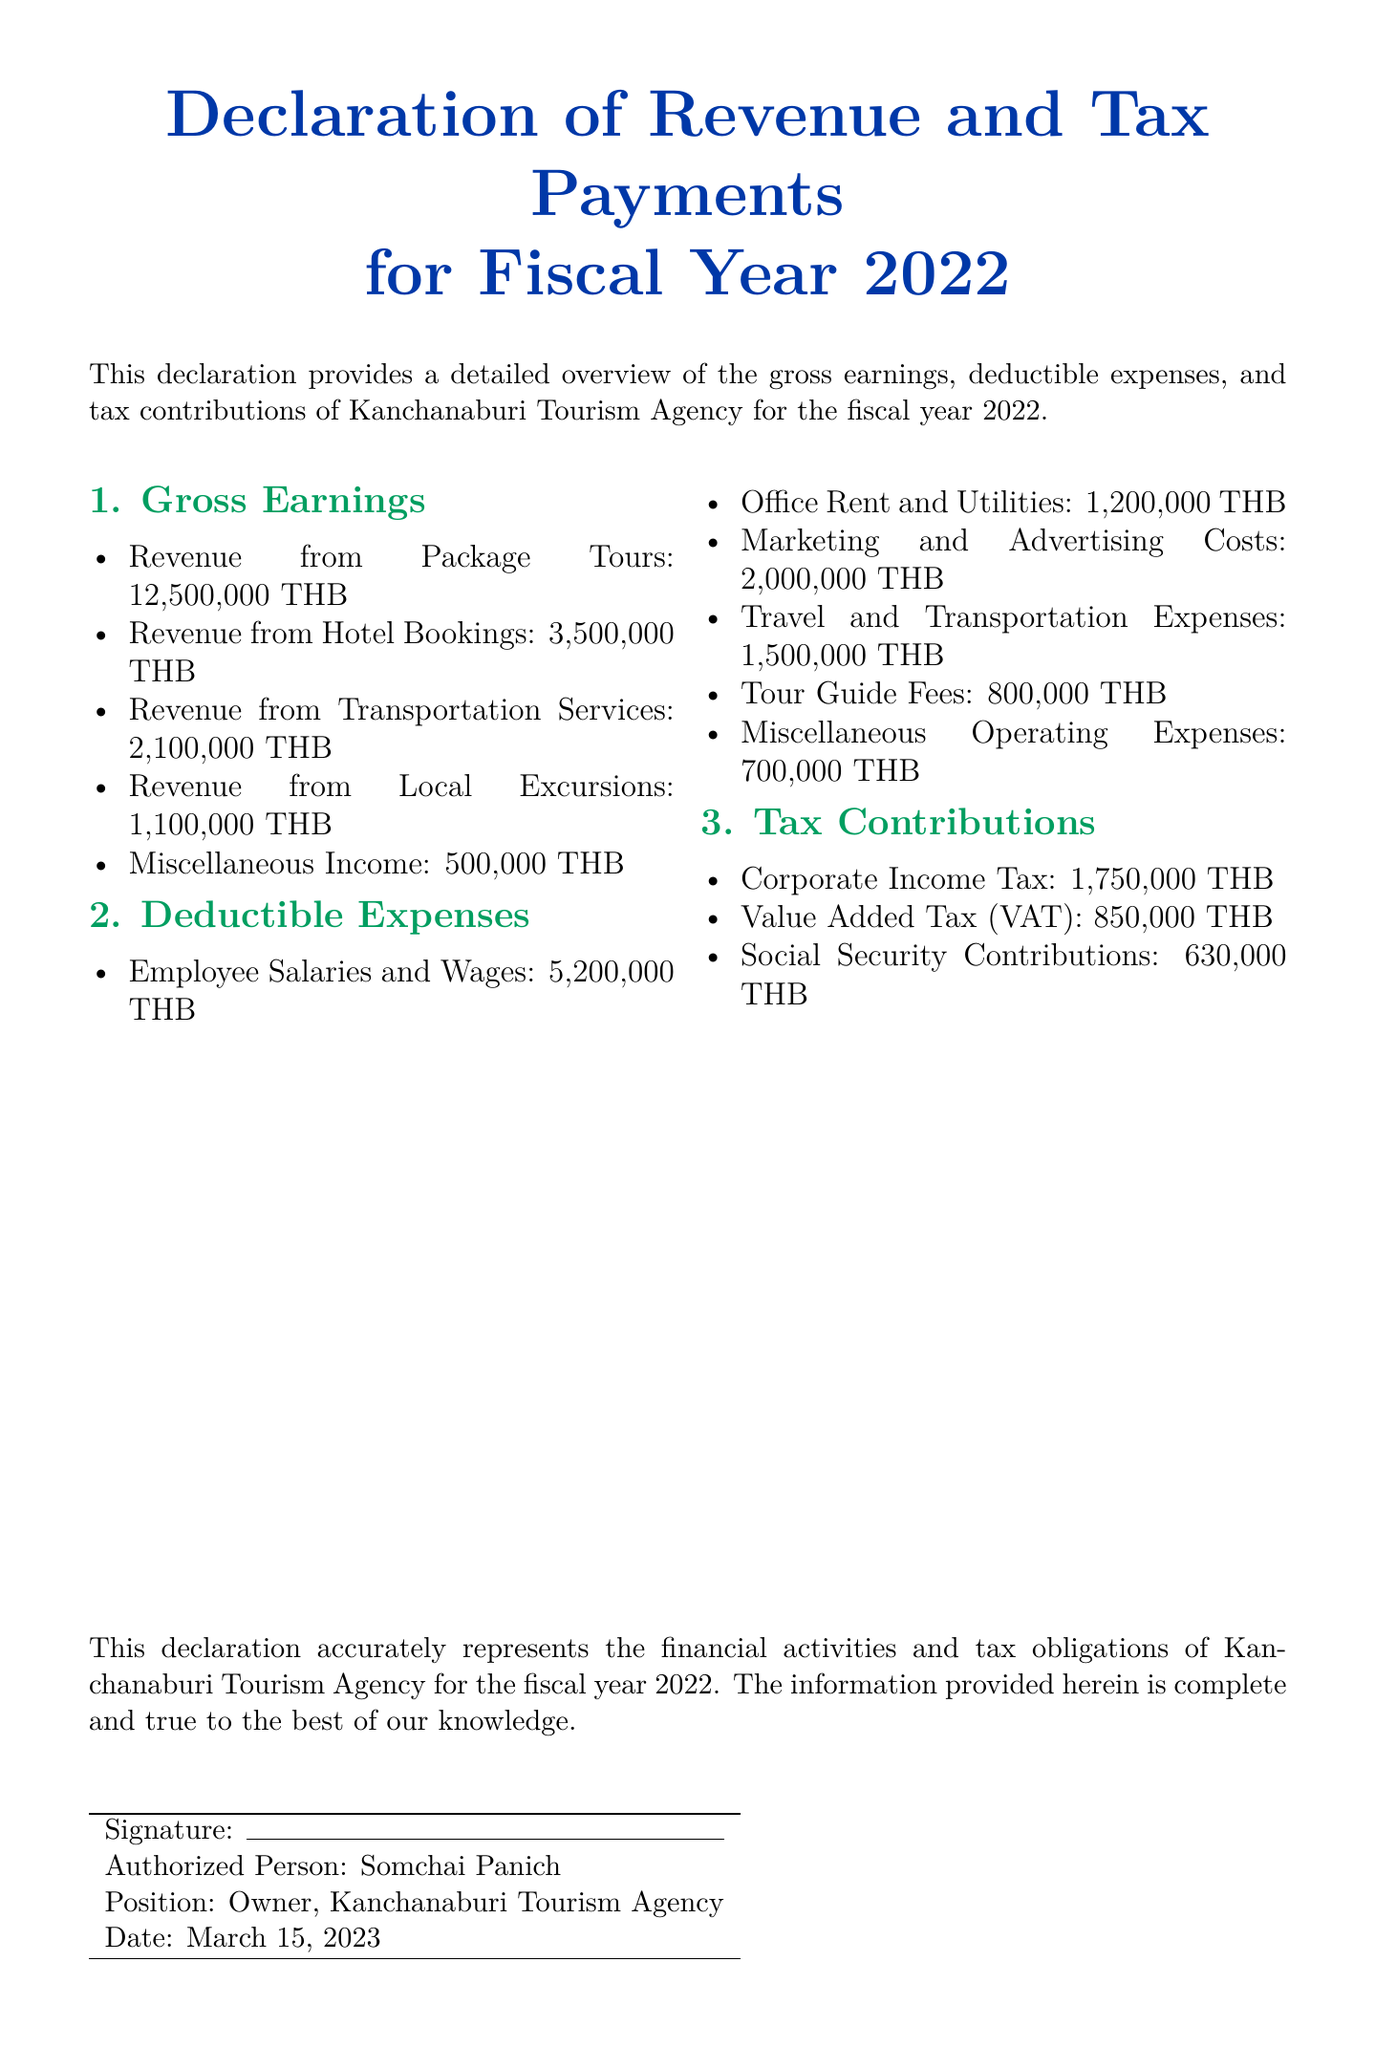What is the total revenue from Package Tours? The total revenue from Package Tours is explicitly stated in the document.
Answer: 12,500,000 THB What is the amount allocated for Employee Salaries and Wages? The amount for Employee Salaries and Wages is listed under deductible expenses.
Answer: 5,200,000 THB What is the date of the declaration? The date of the declaration is mentioned at the end of the document.
Answer: March 15, 2023 Who is the authorized person signing the document? The authorized person is specified in the signature section.
Answer: Somchai Panich How much is contributed for Social Security Contributions? The amount for Social Security Contributions can be found in the tax contributions section.
Answer: 630,000 THB What is the total amount of corporate income tax? The total amount of corporate income tax is clearly noted in the tax contributions section of the document.
Answer: 1,750,000 THB What is the sum of deductible expenses? The sum of deductible expenses requires adding all listed expenses together.
Answer: 12,400,000 THB How many sources of revenue are listed? The document explicitly enumerates the revenue sources provided.
Answer: 5 sources Is the information in the declaration claimed to be accurate? The declaration includes a statement affirming the accuracy of the information.
Answer: Yes 